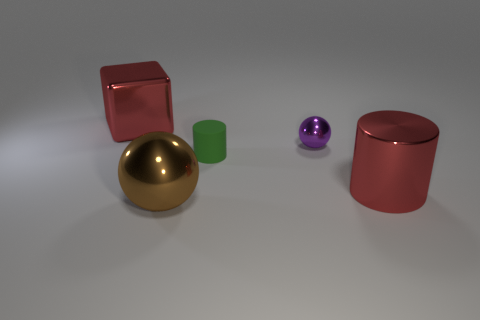Add 1 brown metal blocks. How many objects exist? 6 Subtract all cylinders. How many objects are left? 3 Subtract all matte things. Subtract all big red metal blocks. How many objects are left? 3 Add 4 tiny purple balls. How many tiny purple balls are left? 5 Add 1 purple metal objects. How many purple metal objects exist? 2 Subtract 0 green cubes. How many objects are left? 5 